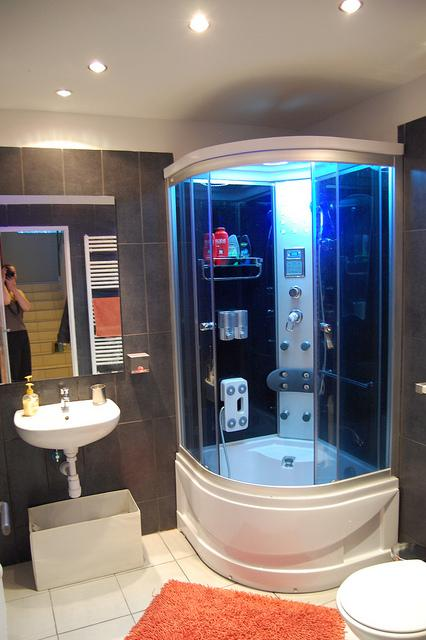What might a person do inside the blue lit area? Please explain your reasoning. shower. This is a place to bathe standing up. 